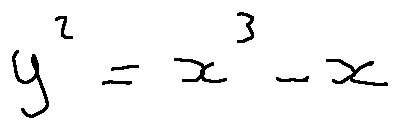Convert formula to latex. <formula><loc_0><loc_0><loc_500><loc_500>y ^ { 2 } = x ^ { 3 } - x</formula> 